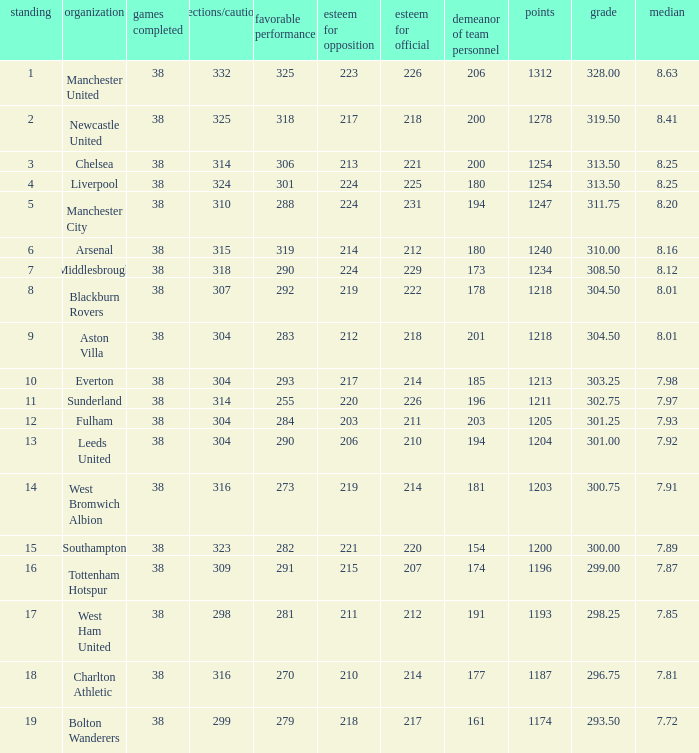Write the full table. {'header': ['standing', 'organization', 'games completed', 'ejections/cautions', 'favorable performance', 'esteem for opposition', 'esteem for official', 'demeanor of team personnel', 'points', 'grade', 'median'], 'rows': [['1', 'Manchester United', '38', '332', '325', '223', '226', '206', '1312', '328.00', '8.63'], ['2', 'Newcastle United', '38', '325', '318', '217', '218', '200', '1278', '319.50', '8.41'], ['3', 'Chelsea', '38', '314', '306', '213', '221', '200', '1254', '313.50', '8.25'], ['4', 'Liverpool', '38', '324', '301', '224', '225', '180', '1254', '313.50', '8.25'], ['5', 'Manchester City', '38', '310', '288', '224', '231', '194', '1247', '311.75', '8.20'], ['6', 'Arsenal', '38', '315', '319', '214', '212', '180', '1240', '310.00', '8.16'], ['7', 'Middlesbrough', '38', '318', '290', '224', '229', '173', '1234', '308.50', '8.12'], ['8', 'Blackburn Rovers', '38', '307', '292', '219', '222', '178', '1218', '304.50', '8.01'], ['9', 'Aston Villa', '38', '304', '283', '212', '218', '201', '1218', '304.50', '8.01'], ['10', 'Everton', '38', '304', '293', '217', '214', '185', '1213', '303.25', '7.98'], ['11', 'Sunderland', '38', '314', '255', '220', '226', '196', '1211', '302.75', '7.97'], ['12', 'Fulham', '38', '304', '284', '203', '211', '203', '1205', '301.25', '7.93'], ['13', 'Leeds United', '38', '304', '290', '206', '210', '194', '1204', '301.00', '7.92'], ['14', 'West Bromwich Albion', '38', '316', '273', '219', '214', '181', '1203', '300.75', '7.91'], ['15', 'Southampton', '38', '323', '282', '221', '220', '154', '1200', '300.00', '7.89'], ['16', 'Tottenham Hotspur', '38', '309', '291', '215', '207', '174', '1196', '299.00', '7.87'], ['17', 'West Ham United', '38', '298', '281', '211', '212', '191', '1193', '298.25', '7.85'], ['18', 'Charlton Athletic', '38', '316', '270', '210', '214', '177', '1187', '296.75', '7.81'], ['19', 'Bolton Wanderers', '38', '299', '279', '218', '217', '161', '1174', '293.50', '7.72']]} Name the points for 212 respect toward opponents 1218.0. 